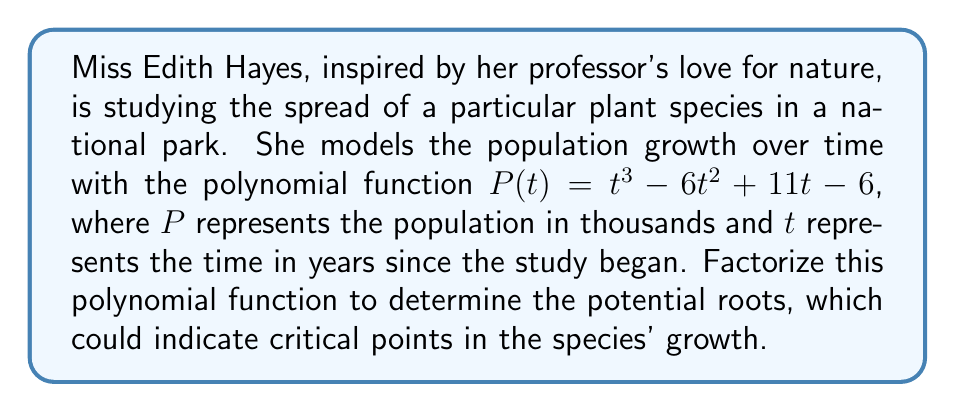Help me with this question. To factorize the polynomial $P(t) = t^3 - 6t^2 + 11t - 6$, we can follow these steps:

1) First, let's check if there are any rational roots using the rational root theorem. The possible rational roots are the factors of the constant term (6): ±1, ±2, ±3, ±6.

2) By testing these values, we find that $t = 1$ is a root of the polynomial.

3) We can factor out $(t - 1)$:
   
   $P(t) = (t - 1)(t^2 - 5t + 6)$

4) Now we need to factor the quadratic term $t^2 - 5t + 6$. We can do this by finding two numbers that multiply to give 6 and add to give -5.

5) These numbers are -2 and -3.

6) Therefore, we can factor the quadratic term as $(t - 2)(t - 3)$.

7) Putting it all together, we get:

   $P(t) = (t - 1)(t - 2)(t - 3)$

This factorization shows that the polynomial has three real roots: 1, 2, and 3. In the context of Miss Hayes' study, these roots could represent critical years in the plant species' growth cycle.
Answer: $P(t) = (t - 1)(t - 2)(t - 3)$ 